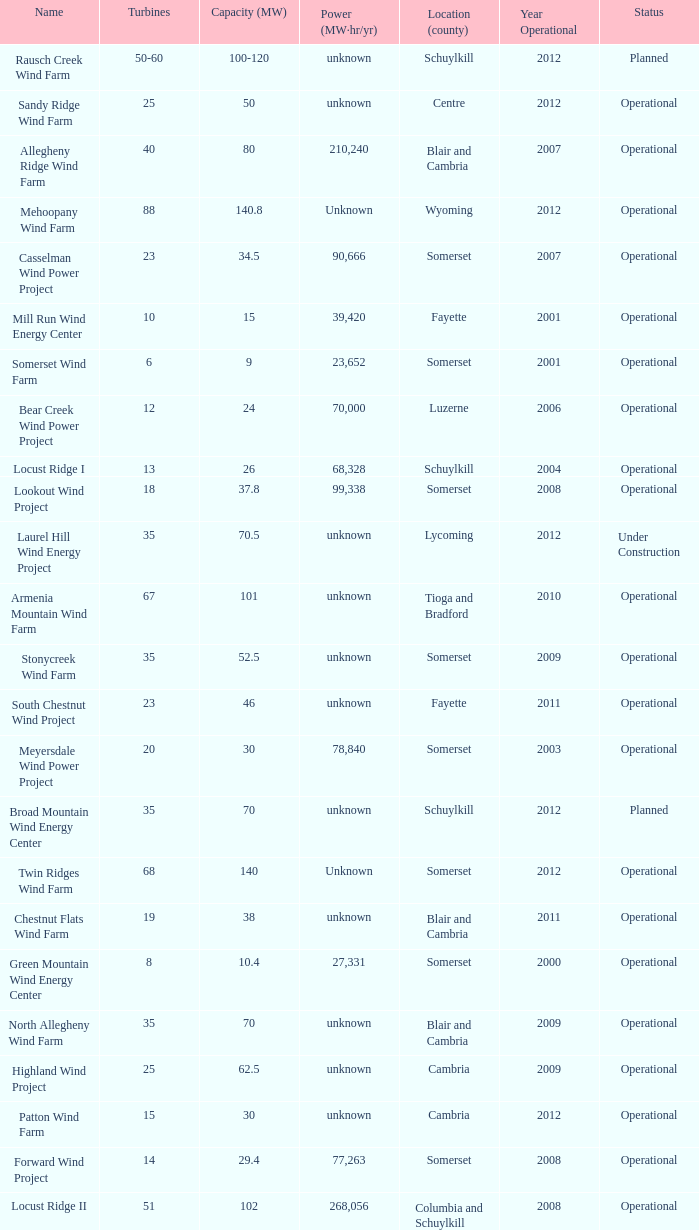What year was Fayette operational at 46? 2011.0. 